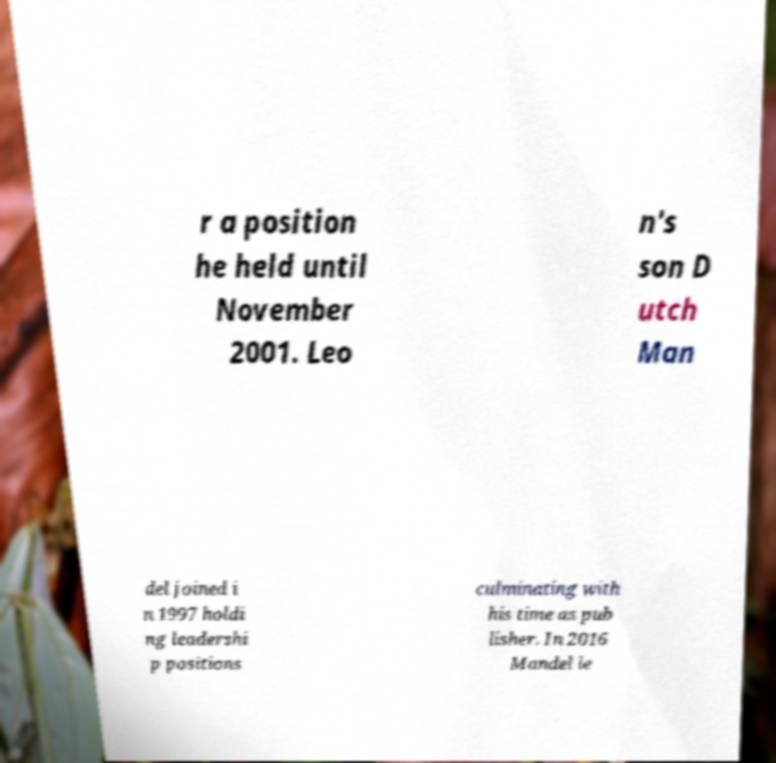Can you accurately transcribe the text from the provided image for me? r a position he held until November 2001. Leo n's son D utch Man del joined i n 1997 holdi ng leadershi p positions culminating with his time as pub lisher. In 2016 Mandel le 